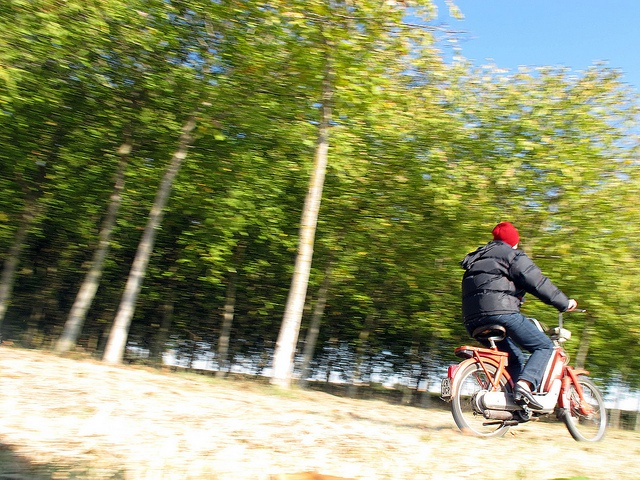Describe the objects in this image and their specific colors. I can see motorcycle in olive, ivory, tan, and black tones and people in olive, black, gray, and darkgray tones in this image. 